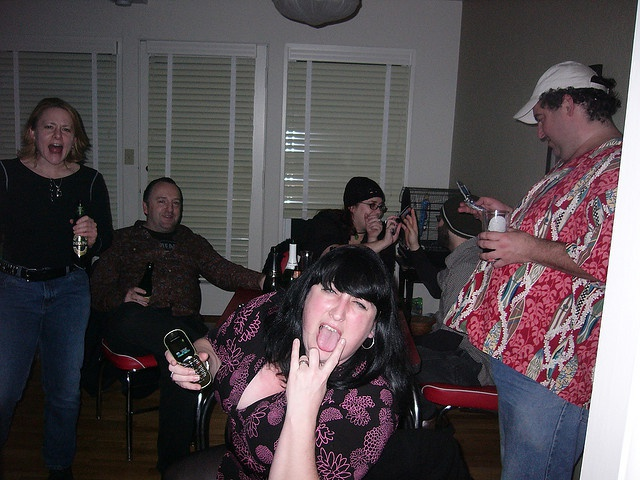Describe the objects in this image and their specific colors. I can see people in black, gray, brown, maroon, and darkgray tones, people in black, pink, lightpink, and purple tones, people in black and brown tones, people in black, gray, and brown tones, and people in black, gray, and maroon tones in this image. 